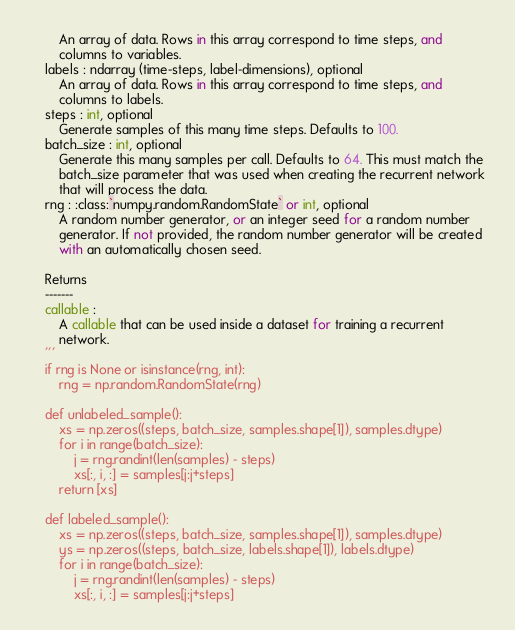<code> <loc_0><loc_0><loc_500><loc_500><_Python_>        An array of data. Rows in this array correspond to time steps, and
        columns to variables.
    labels : ndarray (time-steps, label-dimensions), optional
        An array of data. Rows in this array correspond to time steps, and
        columns to labels.
    steps : int, optional
        Generate samples of this many time steps. Defaults to 100.
    batch_size : int, optional
        Generate this many samples per call. Defaults to 64. This must match the
        batch_size parameter that was used when creating the recurrent network
        that will process the data.
    rng : :class:`numpy.random.RandomState` or int, optional
        A random number generator, or an integer seed for a random number
        generator. If not provided, the random number generator will be created
        with an automatically chosen seed.

    Returns
    -------
    callable :
        A callable that can be used inside a dataset for training a recurrent
        network.
    '''
    if rng is None or isinstance(rng, int):
        rng = np.random.RandomState(rng)

    def unlabeled_sample():
        xs = np.zeros((steps, batch_size, samples.shape[1]), samples.dtype)
        for i in range(batch_size):
            j = rng.randint(len(samples) - steps)
            xs[:, i, :] = samples[j:j+steps]
        return [xs]

    def labeled_sample():
        xs = np.zeros((steps, batch_size, samples.shape[1]), samples.dtype)
        ys = np.zeros((steps, batch_size, labels.shape[1]), labels.dtype)
        for i in range(batch_size):
            j = rng.randint(len(samples) - steps)
            xs[:, i, :] = samples[j:j+steps]</code> 